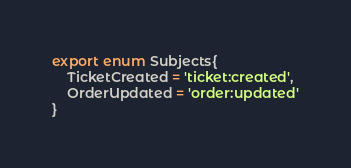Convert code to text. <code><loc_0><loc_0><loc_500><loc_500><_TypeScript_>export enum Subjects{
    TicketCreated = 'ticket:created',
    OrderUpdated = 'order:updated'
}</code> 